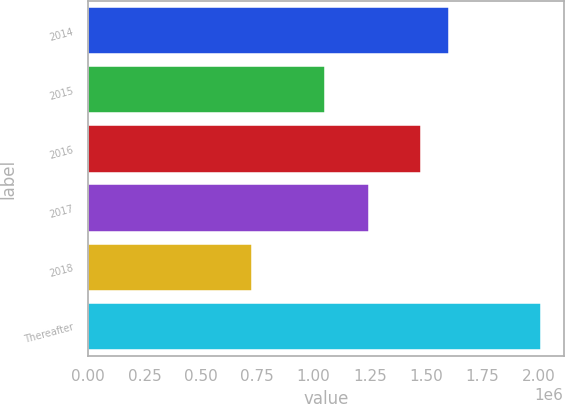<chart> <loc_0><loc_0><loc_500><loc_500><bar_chart><fcel>2014<fcel>2015<fcel>2016<fcel>2017<fcel>2018<fcel>Thereafter<nl><fcel>1.60292e+06<fcel>1.05191e+06<fcel>1.47483e+06<fcel>1.24716e+06<fcel>728276<fcel>2.00925e+06<nl></chart> 